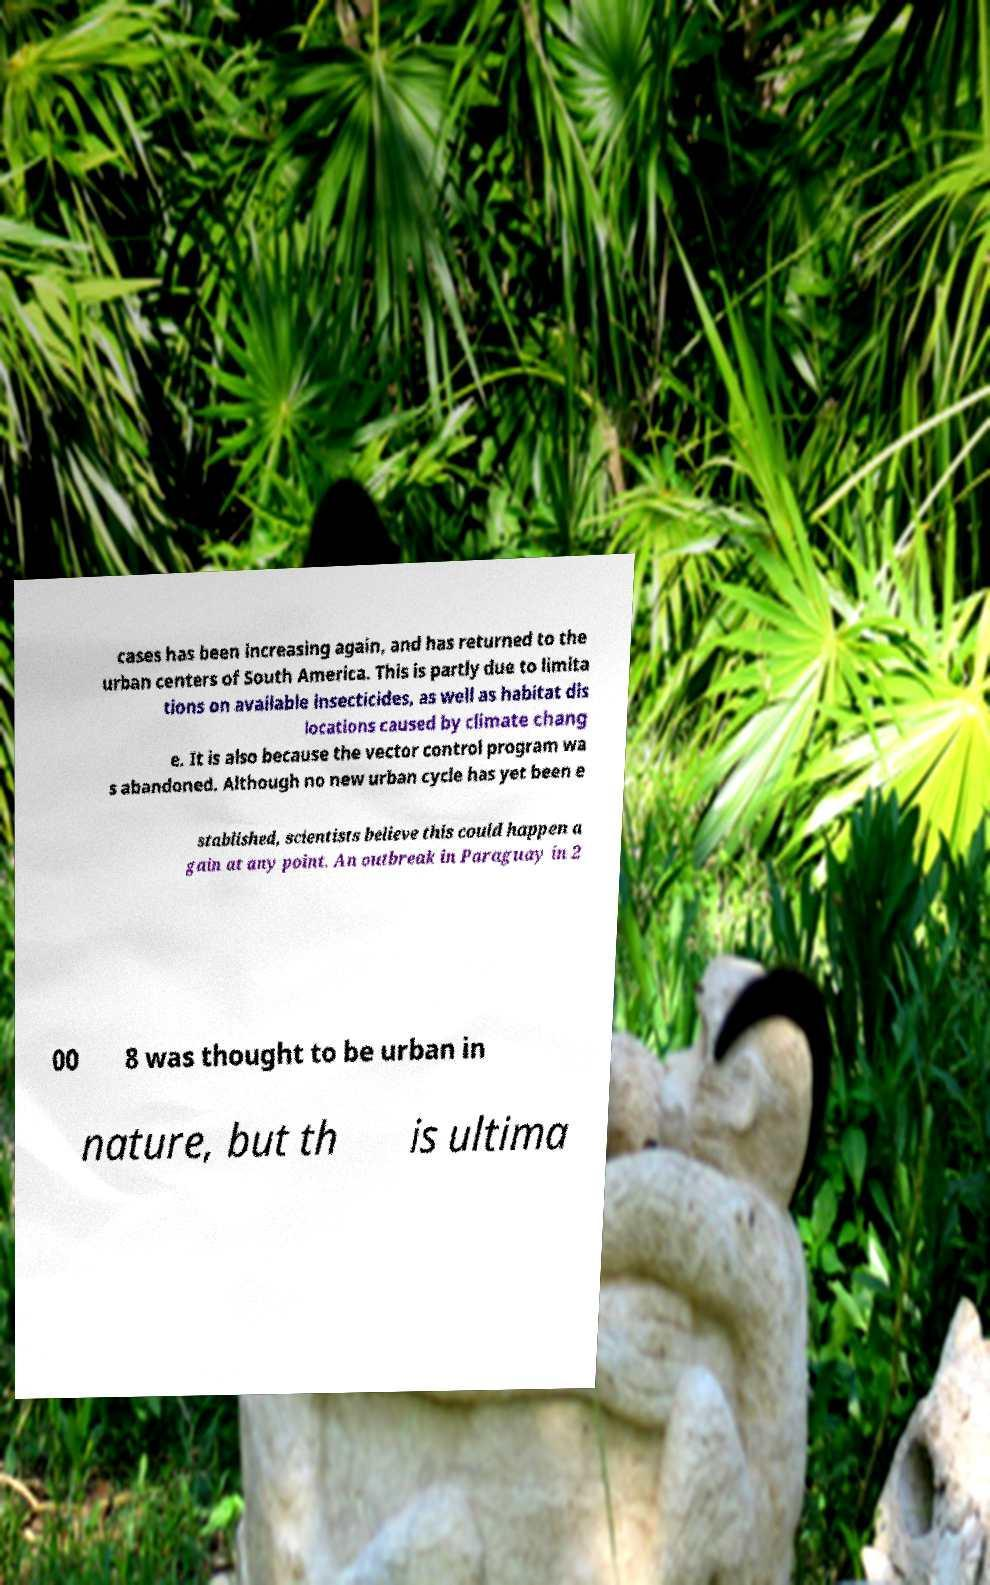I need the written content from this picture converted into text. Can you do that? cases has been increasing again, and has returned to the urban centers of South America. This is partly due to limita tions on available insecticides, as well as habitat dis locations caused by climate chang e. It is also because the vector control program wa s abandoned. Although no new urban cycle has yet been e stablished, scientists believe this could happen a gain at any point. An outbreak in Paraguay in 2 00 8 was thought to be urban in nature, but th is ultima 